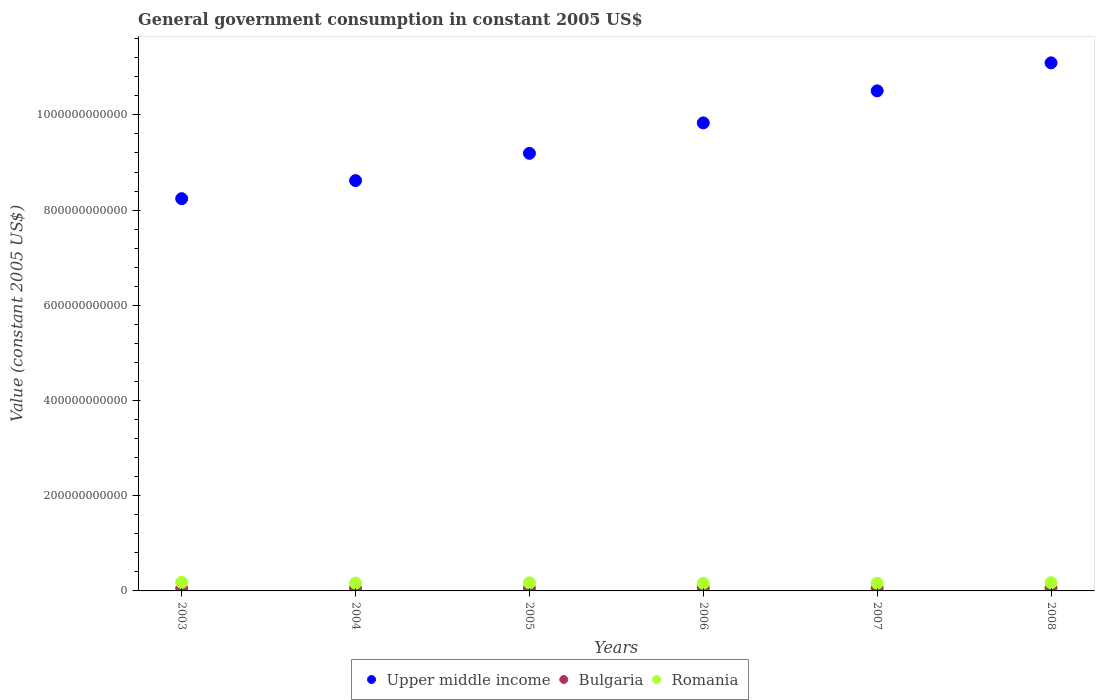How many different coloured dotlines are there?
Provide a short and direct response. 3. Is the number of dotlines equal to the number of legend labels?
Provide a short and direct response. Yes. What is the government conusmption in Romania in 2008?
Make the answer very short. 1.74e+1. Across all years, what is the maximum government conusmption in Bulgaria?
Offer a terse response. 5.94e+09. Across all years, what is the minimum government conusmption in Upper middle income?
Give a very brief answer. 8.24e+11. In which year was the government conusmption in Bulgaria maximum?
Make the answer very short. 2007. In which year was the government conusmption in Romania minimum?
Provide a succinct answer. 2006. What is the total government conusmption in Upper middle income in the graph?
Provide a short and direct response. 5.75e+12. What is the difference between the government conusmption in Romania in 2004 and that in 2005?
Keep it short and to the point. -6.10e+08. What is the difference between the government conusmption in Romania in 2003 and the government conusmption in Bulgaria in 2008?
Provide a short and direct response. 1.20e+1. What is the average government conusmption in Upper middle income per year?
Keep it short and to the point. 9.58e+11. In the year 2008, what is the difference between the government conusmption in Romania and government conusmption in Bulgaria?
Offer a terse response. 1.14e+1. In how many years, is the government conusmption in Upper middle income greater than 80000000000 US$?
Your answer should be very brief. 6. What is the ratio of the government conusmption in Upper middle income in 2003 to that in 2007?
Provide a succinct answer. 0.78. Is the difference between the government conusmption in Romania in 2003 and 2007 greater than the difference between the government conusmption in Bulgaria in 2003 and 2007?
Your answer should be very brief. Yes. What is the difference between the highest and the second highest government conusmption in Bulgaria?
Make the answer very short. 8.86e+06. What is the difference between the highest and the lowest government conusmption in Bulgaria?
Offer a terse response. 6.83e+08. In how many years, is the government conusmption in Bulgaria greater than the average government conusmption in Bulgaria taken over all years?
Make the answer very short. 3. Does the government conusmption in Bulgaria monotonically increase over the years?
Your answer should be very brief. No. Is the government conusmption in Romania strictly greater than the government conusmption in Upper middle income over the years?
Provide a succinct answer. No. How many years are there in the graph?
Your response must be concise. 6. What is the difference between two consecutive major ticks on the Y-axis?
Ensure brevity in your answer.  2.00e+11. Does the graph contain any zero values?
Make the answer very short. No. Does the graph contain grids?
Offer a very short reply. No. How are the legend labels stacked?
Your answer should be very brief. Horizontal. What is the title of the graph?
Your response must be concise. General government consumption in constant 2005 US$. Does "West Bank and Gaza" appear as one of the legend labels in the graph?
Offer a very short reply. No. What is the label or title of the Y-axis?
Offer a very short reply. Value (constant 2005 US$). What is the Value (constant 2005 US$) in Upper middle income in 2003?
Your answer should be compact. 8.24e+11. What is the Value (constant 2005 US$) in Bulgaria in 2003?
Your response must be concise. 5.26e+09. What is the Value (constant 2005 US$) in Romania in 2003?
Keep it short and to the point. 1.79e+1. What is the Value (constant 2005 US$) of Upper middle income in 2004?
Provide a short and direct response. 8.62e+11. What is the Value (constant 2005 US$) of Bulgaria in 2004?
Your answer should be compact. 5.54e+09. What is the Value (constant 2005 US$) in Romania in 2004?
Offer a very short reply. 1.64e+1. What is the Value (constant 2005 US$) in Upper middle income in 2005?
Make the answer very short. 9.19e+11. What is the Value (constant 2005 US$) of Bulgaria in 2005?
Make the answer very short. 5.61e+09. What is the Value (constant 2005 US$) of Romania in 2005?
Offer a very short reply. 1.70e+1. What is the Value (constant 2005 US$) in Upper middle income in 2006?
Keep it short and to the point. 9.83e+11. What is the Value (constant 2005 US$) in Bulgaria in 2006?
Provide a short and direct response. 5.89e+09. What is the Value (constant 2005 US$) in Romania in 2006?
Your response must be concise. 1.62e+1. What is the Value (constant 2005 US$) in Upper middle income in 2007?
Your answer should be compact. 1.05e+12. What is the Value (constant 2005 US$) of Bulgaria in 2007?
Give a very brief answer. 5.94e+09. What is the Value (constant 2005 US$) of Romania in 2007?
Keep it short and to the point. 1.63e+1. What is the Value (constant 2005 US$) in Upper middle income in 2008?
Your answer should be very brief. 1.11e+12. What is the Value (constant 2005 US$) of Bulgaria in 2008?
Keep it short and to the point. 5.93e+09. What is the Value (constant 2005 US$) of Romania in 2008?
Offer a terse response. 1.74e+1. Across all years, what is the maximum Value (constant 2005 US$) of Upper middle income?
Your answer should be very brief. 1.11e+12. Across all years, what is the maximum Value (constant 2005 US$) in Bulgaria?
Provide a short and direct response. 5.94e+09. Across all years, what is the maximum Value (constant 2005 US$) of Romania?
Your answer should be very brief. 1.79e+1. Across all years, what is the minimum Value (constant 2005 US$) of Upper middle income?
Your answer should be compact. 8.24e+11. Across all years, what is the minimum Value (constant 2005 US$) in Bulgaria?
Give a very brief answer. 5.26e+09. Across all years, what is the minimum Value (constant 2005 US$) of Romania?
Provide a succinct answer. 1.62e+1. What is the total Value (constant 2005 US$) in Upper middle income in the graph?
Keep it short and to the point. 5.75e+12. What is the total Value (constant 2005 US$) of Bulgaria in the graph?
Your response must be concise. 3.42e+1. What is the total Value (constant 2005 US$) in Romania in the graph?
Offer a very short reply. 1.01e+11. What is the difference between the Value (constant 2005 US$) of Upper middle income in 2003 and that in 2004?
Give a very brief answer. -3.80e+1. What is the difference between the Value (constant 2005 US$) of Bulgaria in 2003 and that in 2004?
Offer a terse response. -2.78e+08. What is the difference between the Value (constant 2005 US$) of Romania in 2003 and that in 2004?
Make the answer very short. 1.52e+09. What is the difference between the Value (constant 2005 US$) in Upper middle income in 2003 and that in 2005?
Provide a succinct answer. -9.52e+1. What is the difference between the Value (constant 2005 US$) of Bulgaria in 2003 and that in 2005?
Provide a short and direct response. -3.56e+08. What is the difference between the Value (constant 2005 US$) in Romania in 2003 and that in 2005?
Your answer should be compact. 9.09e+08. What is the difference between the Value (constant 2005 US$) of Upper middle income in 2003 and that in 2006?
Offer a terse response. -1.59e+11. What is the difference between the Value (constant 2005 US$) of Bulgaria in 2003 and that in 2006?
Offer a terse response. -6.34e+08. What is the difference between the Value (constant 2005 US$) in Romania in 2003 and that in 2006?
Give a very brief answer. 1.72e+09. What is the difference between the Value (constant 2005 US$) of Upper middle income in 2003 and that in 2007?
Your response must be concise. -2.26e+11. What is the difference between the Value (constant 2005 US$) of Bulgaria in 2003 and that in 2007?
Your answer should be compact. -6.83e+08. What is the difference between the Value (constant 2005 US$) of Romania in 2003 and that in 2007?
Keep it short and to the point. 1.65e+09. What is the difference between the Value (constant 2005 US$) of Upper middle income in 2003 and that in 2008?
Offer a terse response. -2.85e+11. What is the difference between the Value (constant 2005 US$) in Bulgaria in 2003 and that in 2008?
Give a very brief answer. -6.74e+08. What is the difference between the Value (constant 2005 US$) of Romania in 2003 and that in 2008?
Your answer should be compact. 5.60e+08. What is the difference between the Value (constant 2005 US$) of Upper middle income in 2004 and that in 2005?
Keep it short and to the point. -5.72e+1. What is the difference between the Value (constant 2005 US$) in Bulgaria in 2004 and that in 2005?
Your answer should be compact. -7.82e+07. What is the difference between the Value (constant 2005 US$) of Romania in 2004 and that in 2005?
Offer a very short reply. -6.10e+08. What is the difference between the Value (constant 2005 US$) in Upper middle income in 2004 and that in 2006?
Provide a succinct answer. -1.21e+11. What is the difference between the Value (constant 2005 US$) in Bulgaria in 2004 and that in 2006?
Offer a terse response. -3.56e+08. What is the difference between the Value (constant 2005 US$) in Romania in 2004 and that in 2006?
Your response must be concise. 2.02e+08. What is the difference between the Value (constant 2005 US$) in Upper middle income in 2004 and that in 2007?
Make the answer very short. -1.89e+11. What is the difference between the Value (constant 2005 US$) of Bulgaria in 2004 and that in 2007?
Your answer should be very brief. -4.04e+08. What is the difference between the Value (constant 2005 US$) of Romania in 2004 and that in 2007?
Keep it short and to the point. 1.31e+08. What is the difference between the Value (constant 2005 US$) of Upper middle income in 2004 and that in 2008?
Provide a succinct answer. -2.47e+11. What is the difference between the Value (constant 2005 US$) in Bulgaria in 2004 and that in 2008?
Keep it short and to the point. -3.95e+08. What is the difference between the Value (constant 2005 US$) in Romania in 2004 and that in 2008?
Offer a very short reply. -9.59e+08. What is the difference between the Value (constant 2005 US$) of Upper middle income in 2005 and that in 2006?
Make the answer very short. -6.40e+1. What is the difference between the Value (constant 2005 US$) in Bulgaria in 2005 and that in 2006?
Keep it short and to the point. -2.78e+08. What is the difference between the Value (constant 2005 US$) of Romania in 2005 and that in 2006?
Provide a succinct answer. 8.12e+08. What is the difference between the Value (constant 2005 US$) of Upper middle income in 2005 and that in 2007?
Provide a short and direct response. -1.31e+11. What is the difference between the Value (constant 2005 US$) in Bulgaria in 2005 and that in 2007?
Ensure brevity in your answer.  -3.26e+08. What is the difference between the Value (constant 2005 US$) in Romania in 2005 and that in 2007?
Your answer should be compact. 7.41e+08. What is the difference between the Value (constant 2005 US$) in Upper middle income in 2005 and that in 2008?
Provide a short and direct response. -1.90e+11. What is the difference between the Value (constant 2005 US$) in Bulgaria in 2005 and that in 2008?
Provide a succinct answer. -3.17e+08. What is the difference between the Value (constant 2005 US$) in Romania in 2005 and that in 2008?
Your response must be concise. -3.49e+08. What is the difference between the Value (constant 2005 US$) in Upper middle income in 2006 and that in 2007?
Your answer should be compact. -6.73e+1. What is the difference between the Value (constant 2005 US$) in Bulgaria in 2006 and that in 2007?
Offer a terse response. -4.85e+07. What is the difference between the Value (constant 2005 US$) in Romania in 2006 and that in 2007?
Offer a very short reply. -7.13e+07. What is the difference between the Value (constant 2005 US$) in Upper middle income in 2006 and that in 2008?
Your response must be concise. -1.26e+11. What is the difference between the Value (constant 2005 US$) of Bulgaria in 2006 and that in 2008?
Offer a very short reply. -3.97e+07. What is the difference between the Value (constant 2005 US$) in Romania in 2006 and that in 2008?
Ensure brevity in your answer.  -1.16e+09. What is the difference between the Value (constant 2005 US$) of Upper middle income in 2007 and that in 2008?
Keep it short and to the point. -5.88e+1. What is the difference between the Value (constant 2005 US$) in Bulgaria in 2007 and that in 2008?
Make the answer very short. 8.86e+06. What is the difference between the Value (constant 2005 US$) of Romania in 2007 and that in 2008?
Make the answer very short. -1.09e+09. What is the difference between the Value (constant 2005 US$) of Upper middle income in 2003 and the Value (constant 2005 US$) of Bulgaria in 2004?
Offer a very short reply. 8.19e+11. What is the difference between the Value (constant 2005 US$) in Upper middle income in 2003 and the Value (constant 2005 US$) in Romania in 2004?
Provide a succinct answer. 8.08e+11. What is the difference between the Value (constant 2005 US$) of Bulgaria in 2003 and the Value (constant 2005 US$) of Romania in 2004?
Your response must be concise. -1.11e+1. What is the difference between the Value (constant 2005 US$) of Upper middle income in 2003 and the Value (constant 2005 US$) of Bulgaria in 2005?
Your answer should be compact. 8.18e+11. What is the difference between the Value (constant 2005 US$) of Upper middle income in 2003 and the Value (constant 2005 US$) of Romania in 2005?
Your answer should be very brief. 8.07e+11. What is the difference between the Value (constant 2005 US$) of Bulgaria in 2003 and the Value (constant 2005 US$) of Romania in 2005?
Your response must be concise. -1.18e+1. What is the difference between the Value (constant 2005 US$) in Upper middle income in 2003 and the Value (constant 2005 US$) in Bulgaria in 2006?
Ensure brevity in your answer.  8.18e+11. What is the difference between the Value (constant 2005 US$) of Upper middle income in 2003 and the Value (constant 2005 US$) of Romania in 2006?
Your answer should be very brief. 8.08e+11. What is the difference between the Value (constant 2005 US$) of Bulgaria in 2003 and the Value (constant 2005 US$) of Romania in 2006?
Keep it short and to the point. -1.09e+1. What is the difference between the Value (constant 2005 US$) of Upper middle income in 2003 and the Value (constant 2005 US$) of Bulgaria in 2007?
Ensure brevity in your answer.  8.18e+11. What is the difference between the Value (constant 2005 US$) in Upper middle income in 2003 and the Value (constant 2005 US$) in Romania in 2007?
Offer a terse response. 8.08e+11. What is the difference between the Value (constant 2005 US$) of Bulgaria in 2003 and the Value (constant 2005 US$) of Romania in 2007?
Your answer should be compact. -1.10e+1. What is the difference between the Value (constant 2005 US$) in Upper middle income in 2003 and the Value (constant 2005 US$) in Bulgaria in 2008?
Your answer should be compact. 8.18e+11. What is the difference between the Value (constant 2005 US$) in Upper middle income in 2003 and the Value (constant 2005 US$) in Romania in 2008?
Make the answer very short. 8.07e+11. What is the difference between the Value (constant 2005 US$) of Bulgaria in 2003 and the Value (constant 2005 US$) of Romania in 2008?
Offer a terse response. -1.21e+1. What is the difference between the Value (constant 2005 US$) of Upper middle income in 2004 and the Value (constant 2005 US$) of Bulgaria in 2005?
Make the answer very short. 8.56e+11. What is the difference between the Value (constant 2005 US$) of Upper middle income in 2004 and the Value (constant 2005 US$) of Romania in 2005?
Offer a terse response. 8.45e+11. What is the difference between the Value (constant 2005 US$) in Bulgaria in 2004 and the Value (constant 2005 US$) in Romania in 2005?
Provide a succinct answer. -1.15e+1. What is the difference between the Value (constant 2005 US$) of Upper middle income in 2004 and the Value (constant 2005 US$) of Bulgaria in 2006?
Provide a short and direct response. 8.56e+11. What is the difference between the Value (constant 2005 US$) in Upper middle income in 2004 and the Value (constant 2005 US$) in Romania in 2006?
Provide a short and direct response. 8.46e+11. What is the difference between the Value (constant 2005 US$) of Bulgaria in 2004 and the Value (constant 2005 US$) of Romania in 2006?
Offer a very short reply. -1.07e+1. What is the difference between the Value (constant 2005 US$) in Upper middle income in 2004 and the Value (constant 2005 US$) in Bulgaria in 2007?
Offer a very short reply. 8.56e+11. What is the difference between the Value (constant 2005 US$) in Upper middle income in 2004 and the Value (constant 2005 US$) in Romania in 2007?
Make the answer very short. 8.46e+11. What is the difference between the Value (constant 2005 US$) in Bulgaria in 2004 and the Value (constant 2005 US$) in Romania in 2007?
Ensure brevity in your answer.  -1.07e+1. What is the difference between the Value (constant 2005 US$) in Upper middle income in 2004 and the Value (constant 2005 US$) in Bulgaria in 2008?
Offer a very short reply. 8.56e+11. What is the difference between the Value (constant 2005 US$) in Upper middle income in 2004 and the Value (constant 2005 US$) in Romania in 2008?
Make the answer very short. 8.45e+11. What is the difference between the Value (constant 2005 US$) in Bulgaria in 2004 and the Value (constant 2005 US$) in Romania in 2008?
Your answer should be compact. -1.18e+1. What is the difference between the Value (constant 2005 US$) of Upper middle income in 2005 and the Value (constant 2005 US$) of Bulgaria in 2006?
Provide a succinct answer. 9.13e+11. What is the difference between the Value (constant 2005 US$) of Upper middle income in 2005 and the Value (constant 2005 US$) of Romania in 2006?
Offer a terse response. 9.03e+11. What is the difference between the Value (constant 2005 US$) in Bulgaria in 2005 and the Value (constant 2005 US$) in Romania in 2006?
Your answer should be very brief. -1.06e+1. What is the difference between the Value (constant 2005 US$) of Upper middle income in 2005 and the Value (constant 2005 US$) of Bulgaria in 2007?
Provide a succinct answer. 9.13e+11. What is the difference between the Value (constant 2005 US$) in Upper middle income in 2005 and the Value (constant 2005 US$) in Romania in 2007?
Provide a succinct answer. 9.03e+11. What is the difference between the Value (constant 2005 US$) in Bulgaria in 2005 and the Value (constant 2005 US$) in Romania in 2007?
Make the answer very short. -1.07e+1. What is the difference between the Value (constant 2005 US$) of Upper middle income in 2005 and the Value (constant 2005 US$) of Bulgaria in 2008?
Your answer should be very brief. 9.13e+11. What is the difference between the Value (constant 2005 US$) in Upper middle income in 2005 and the Value (constant 2005 US$) in Romania in 2008?
Your answer should be very brief. 9.02e+11. What is the difference between the Value (constant 2005 US$) of Bulgaria in 2005 and the Value (constant 2005 US$) of Romania in 2008?
Offer a terse response. -1.17e+1. What is the difference between the Value (constant 2005 US$) in Upper middle income in 2006 and the Value (constant 2005 US$) in Bulgaria in 2007?
Give a very brief answer. 9.77e+11. What is the difference between the Value (constant 2005 US$) of Upper middle income in 2006 and the Value (constant 2005 US$) of Romania in 2007?
Give a very brief answer. 9.67e+11. What is the difference between the Value (constant 2005 US$) of Bulgaria in 2006 and the Value (constant 2005 US$) of Romania in 2007?
Offer a terse response. -1.04e+1. What is the difference between the Value (constant 2005 US$) in Upper middle income in 2006 and the Value (constant 2005 US$) in Bulgaria in 2008?
Your answer should be compact. 9.77e+11. What is the difference between the Value (constant 2005 US$) of Upper middle income in 2006 and the Value (constant 2005 US$) of Romania in 2008?
Your answer should be compact. 9.66e+11. What is the difference between the Value (constant 2005 US$) in Bulgaria in 2006 and the Value (constant 2005 US$) in Romania in 2008?
Keep it short and to the point. -1.15e+1. What is the difference between the Value (constant 2005 US$) of Upper middle income in 2007 and the Value (constant 2005 US$) of Bulgaria in 2008?
Your answer should be very brief. 1.04e+12. What is the difference between the Value (constant 2005 US$) in Upper middle income in 2007 and the Value (constant 2005 US$) in Romania in 2008?
Give a very brief answer. 1.03e+12. What is the difference between the Value (constant 2005 US$) of Bulgaria in 2007 and the Value (constant 2005 US$) of Romania in 2008?
Offer a terse response. -1.14e+1. What is the average Value (constant 2005 US$) of Upper middle income per year?
Provide a short and direct response. 9.58e+11. What is the average Value (constant 2005 US$) in Bulgaria per year?
Your response must be concise. 5.70e+09. What is the average Value (constant 2005 US$) in Romania per year?
Give a very brief answer. 1.69e+1. In the year 2003, what is the difference between the Value (constant 2005 US$) in Upper middle income and Value (constant 2005 US$) in Bulgaria?
Your response must be concise. 8.19e+11. In the year 2003, what is the difference between the Value (constant 2005 US$) of Upper middle income and Value (constant 2005 US$) of Romania?
Your answer should be compact. 8.06e+11. In the year 2003, what is the difference between the Value (constant 2005 US$) of Bulgaria and Value (constant 2005 US$) of Romania?
Offer a terse response. -1.27e+1. In the year 2004, what is the difference between the Value (constant 2005 US$) of Upper middle income and Value (constant 2005 US$) of Bulgaria?
Your answer should be compact. 8.57e+11. In the year 2004, what is the difference between the Value (constant 2005 US$) of Upper middle income and Value (constant 2005 US$) of Romania?
Provide a succinct answer. 8.46e+11. In the year 2004, what is the difference between the Value (constant 2005 US$) of Bulgaria and Value (constant 2005 US$) of Romania?
Provide a succinct answer. -1.09e+1. In the year 2005, what is the difference between the Value (constant 2005 US$) in Upper middle income and Value (constant 2005 US$) in Bulgaria?
Give a very brief answer. 9.14e+11. In the year 2005, what is the difference between the Value (constant 2005 US$) of Upper middle income and Value (constant 2005 US$) of Romania?
Give a very brief answer. 9.02e+11. In the year 2005, what is the difference between the Value (constant 2005 US$) in Bulgaria and Value (constant 2005 US$) in Romania?
Your response must be concise. -1.14e+1. In the year 2006, what is the difference between the Value (constant 2005 US$) in Upper middle income and Value (constant 2005 US$) in Bulgaria?
Provide a succinct answer. 9.77e+11. In the year 2006, what is the difference between the Value (constant 2005 US$) of Upper middle income and Value (constant 2005 US$) of Romania?
Provide a succinct answer. 9.67e+11. In the year 2006, what is the difference between the Value (constant 2005 US$) in Bulgaria and Value (constant 2005 US$) in Romania?
Your answer should be very brief. -1.03e+1. In the year 2007, what is the difference between the Value (constant 2005 US$) in Upper middle income and Value (constant 2005 US$) in Bulgaria?
Offer a very short reply. 1.04e+12. In the year 2007, what is the difference between the Value (constant 2005 US$) of Upper middle income and Value (constant 2005 US$) of Romania?
Give a very brief answer. 1.03e+12. In the year 2007, what is the difference between the Value (constant 2005 US$) of Bulgaria and Value (constant 2005 US$) of Romania?
Keep it short and to the point. -1.03e+1. In the year 2008, what is the difference between the Value (constant 2005 US$) in Upper middle income and Value (constant 2005 US$) in Bulgaria?
Give a very brief answer. 1.10e+12. In the year 2008, what is the difference between the Value (constant 2005 US$) in Upper middle income and Value (constant 2005 US$) in Romania?
Ensure brevity in your answer.  1.09e+12. In the year 2008, what is the difference between the Value (constant 2005 US$) in Bulgaria and Value (constant 2005 US$) in Romania?
Offer a very short reply. -1.14e+1. What is the ratio of the Value (constant 2005 US$) of Upper middle income in 2003 to that in 2004?
Make the answer very short. 0.96. What is the ratio of the Value (constant 2005 US$) in Bulgaria in 2003 to that in 2004?
Offer a very short reply. 0.95. What is the ratio of the Value (constant 2005 US$) of Romania in 2003 to that in 2004?
Your answer should be very brief. 1.09. What is the ratio of the Value (constant 2005 US$) in Upper middle income in 2003 to that in 2005?
Keep it short and to the point. 0.9. What is the ratio of the Value (constant 2005 US$) of Bulgaria in 2003 to that in 2005?
Offer a terse response. 0.94. What is the ratio of the Value (constant 2005 US$) of Romania in 2003 to that in 2005?
Keep it short and to the point. 1.05. What is the ratio of the Value (constant 2005 US$) in Upper middle income in 2003 to that in 2006?
Provide a short and direct response. 0.84. What is the ratio of the Value (constant 2005 US$) in Bulgaria in 2003 to that in 2006?
Your answer should be very brief. 0.89. What is the ratio of the Value (constant 2005 US$) of Romania in 2003 to that in 2006?
Ensure brevity in your answer.  1.11. What is the ratio of the Value (constant 2005 US$) of Upper middle income in 2003 to that in 2007?
Give a very brief answer. 0.78. What is the ratio of the Value (constant 2005 US$) in Bulgaria in 2003 to that in 2007?
Ensure brevity in your answer.  0.89. What is the ratio of the Value (constant 2005 US$) in Romania in 2003 to that in 2007?
Your answer should be very brief. 1.1. What is the ratio of the Value (constant 2005 US$) in Upper middle income in 2003 to that in 2008?
Offer a terse response. 0.74. What is the ratio of the Value (constant 2005 US$) in Bulgaria in 2003 to that in 2008?
Provide a succinct answer. 0.89. What is the ratio of the Value (constant 2005 US$) of Romania in 2003 to that in 2008?
Your answer should be very brief. 1.03. What is the ratio of the Value (constant 2005 US$) in Upper middle income in 2004 to that in 2005?
Ensure brevity in your answer.  0.94. What is the ratio of the Value (constant 2005 US$) of Bulgaria in 2004 to that in 2005?
Give a very brief answer. 0.99. What is the ratio of the Value (constant 2005 US$) of Romania in 2004 to that in 2005?
Provide a succinct answer. 0.96. What is the ratio of the Value (constant 2005 US$) in Upper middle income in 2004 to that in 2006?
Ensure brevity in your answer.  0.88. What is the ratio of the Value (constant 2005 US$) in Bulgaria in 2004 to that in 2006?
Ensure brevity in your answer.  0.94. What is the ratio of the Value (constant 2005 US$) of Romania in 2004 to that in 2006?
Your answer should be compact. 1.01. What is the ratio of the Value (constant 2005 US$) of Upper middle income in 2004 to that in 2007?
Ensure brevity in your answer.  0.82. What is the ratio of the Value (constant 2005 US$) in Bulgaria in 2004 to that in 2007?
Your answer should be compact. 0.93. What is the ratio of the Value (constant 2005 US$) of Upper middle income in 2004 to that in 2008?
Make the answer very short. 0.78. What is the ratio of the Value (constant 2005 US$) in Romania in 2004 to that in 2008?
Make the answer very short. 0.94. What is the ratio of the Value (constant 2005 US$) of Upper middle income in 2005 to that in 2006?
Keep it short and to the point. 0.94. What is the ratio of the Value (constant 2005 US$) in Bulgaria in 2005 to that in 2006?
Keep it short and to the point. 0.95. What is the ratio of the Value (constant 2005 US$) of Romania in 2005 to that in 2006?
Offer a very short reply. 1.05. What is the ratio of the Value (constant 2005 US$) of Upper middle income in 2005 to that in 2007?
Make the answer very short. 0.88. What is the ratio of the Value (constant 2005 US$) in Bulgaria in 2005 to that in 2007?
Your response must be concise. 0.95. What is the ratio of the Value (constant 2005 US$) of Romania in 2005 to that in 2007?
Provide a short and direct response. 1.05. What is the ratio of the Value (constant 2005 US$) of Upper middle income in 2005 to that in 2008?
Your answer should be compact. 0.83. What is the ratio of the Value (constant 2005 US$) of Bulgaria in 2005 to that in 2008?
Keep it short and to the point. 0.95. What is the ratio of the Value (constant 2005 US$) in Romania in 2005 to that in 2008?
Offer a terse response. 0.98. What is the ratio of the Value (constant 2005 US$) of Upper middle income in 2006 to that in 2007?
Ensure brevity in your answer.  0.94. What is the ratio of the Value (constant 2005 US$) of Bulgaria in 2006 to that in 2007?
Your answer should be compact. 0.99. What is the ratio of the Value (constant 2005 US$) of Romania in 2006 to that in 2007?
Make the answer very short. 1. What is the ratio of the Value (constant 2005 US$) in Upper middle income in 2006 to that in 2008?
Your answer should be compact. 0.89. What is the ratio of the Value (constant 2005 US$) in Bulgaria in 2006 to that in 2008?
Ensure brevity in your answer.  0.99. What is the ratio of the Value (constant 2005 US$) of Romania in 2006 to that in 2008?
Your response must be concise. 0.93. What is the ratio of the Value (constant 2005 US$) of Upper middle income in 2007 to that in 2008?
Offer a very short reply. 0.95. What is the ratio of the Value (constant 2005 US$) of Bulgaria in 2007 to that in 2008?
Offer a very short reply. 1. What is the ratio of the Value (constant 2005 US$) of Romania in 2007 to that in 2008?
Your answer should be very brief. 0.94. What is the difference between the highest and the second highest Value (constant 2005 US$) of Upper middle income?
Make the answer very short. 5.88e+1. What is the difference between the highest and the second highest Value (constant 2005 US$) of Bulgaria?
Give a very brief answer. 8.86e+06. What is the difference between the highest and the second highest Value (constant 2005 US$) of Romania?
Offer a very short reply. 5.60e+08. What is the difference between the highest and the lowest Value (constant 2005 US$) in Upper middle income?
Offer a very short reply. 2.85e+11. What is the difference between the highest and the lowest Value (constant 2005 US$) in Bulgaria?
Provide a succinct answer. 6.83e+08. What is the difference between the highest and the lowest Value (constant 2005 US$) of Romania?
Provide a succinct answer. 1.72e+09. 